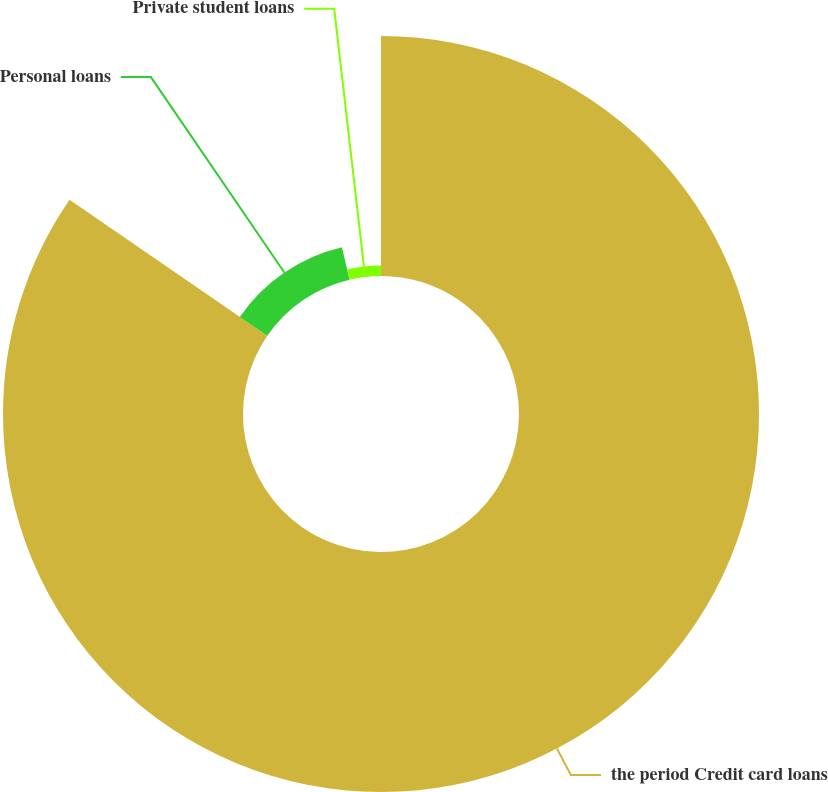Convert chart to OTSL. <chart><loc_0><loc_0><loc_500><loc_500><pie_chart><fcel>the period Credit card loans<fcel>Personal loans<fcel>Private student loans<nl><fcel>84.58%<fcel>11.75%<fcel>3.66%<nl></chart> 